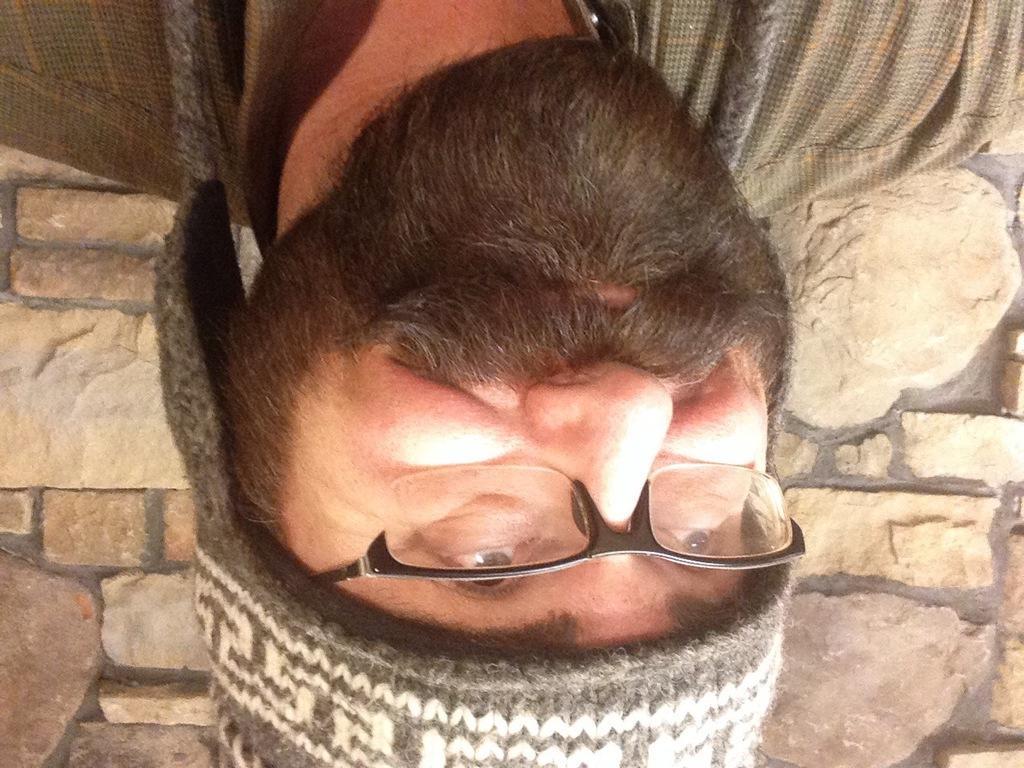In one or two sentences, can you explain what this image depicts? In the foreground of this image, there is a man´s face upside down and in the background, there is a wall. 